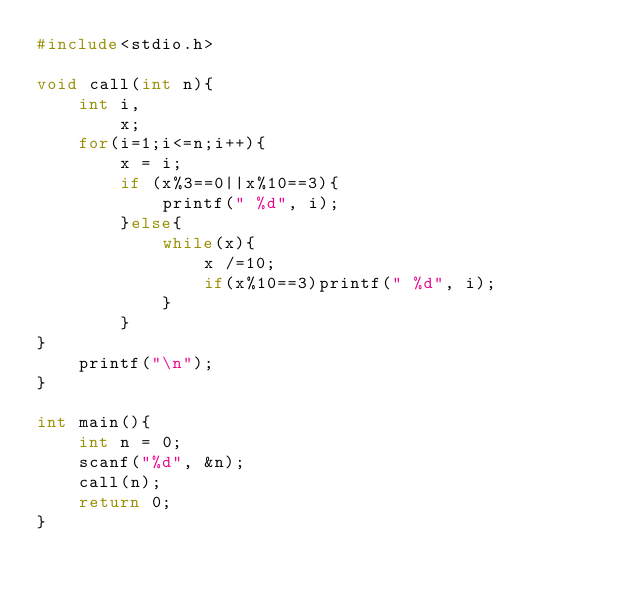Convert code to text. <code><loc_0><loc_0><loc_500><loc_500><_C_>#include<stdio.h>

void call(int n){
    int i,
        x;
    for(i=1;i<=n;i++){
        x = i;
        if (x%3==0||x%10==3){
            printf(" %d", i);
        }else{
            while(x){
                x /=10;
                if(x%10==3)printf(" %d", i);
            }
        }
}
    printf("\n");
}

int main(){
    int n = 0;
    scanf("%d", &n);
    call(n);
    return 0;
}</code> 